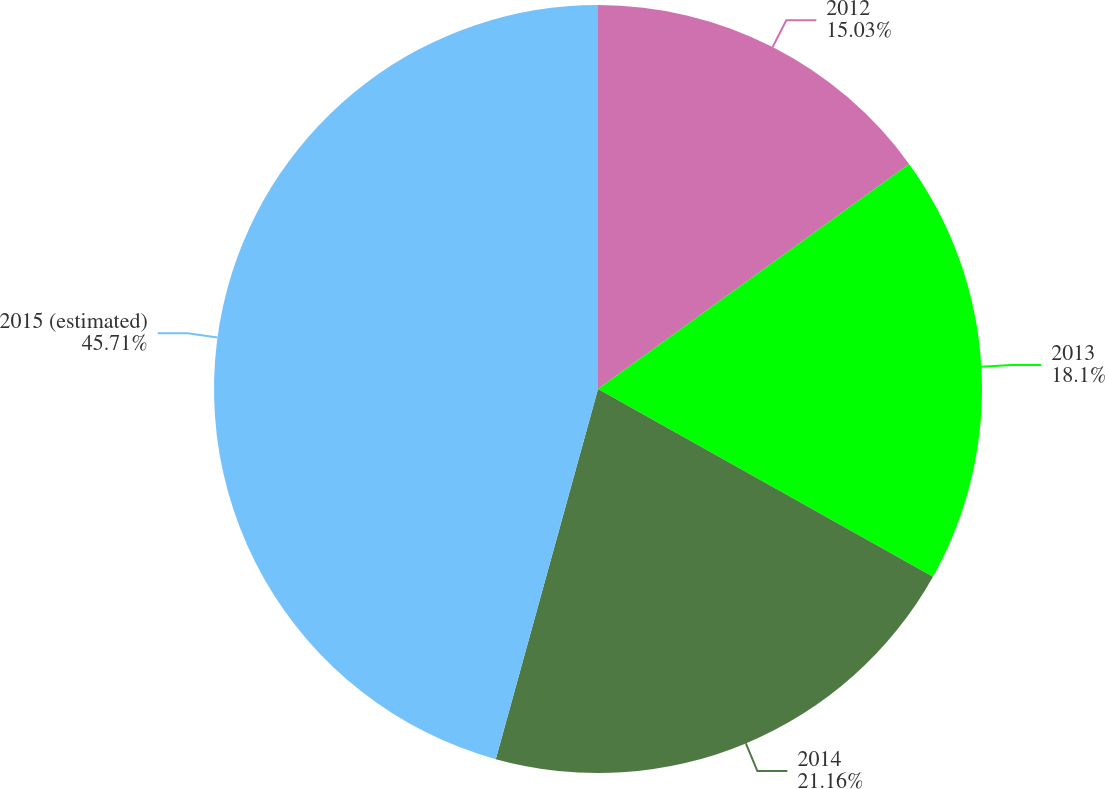Convert chart to OTSL. <chart><loc_0><loc_0><loc_500><loc_500><pie_chart><fcel>2012<fcel>2013<fcel>2014<fcel>2015 (estimated)<nl><fcel>15.03%<fcel>18.1%<fcel>21.16%<fcel>45.71%<nl></chart> 